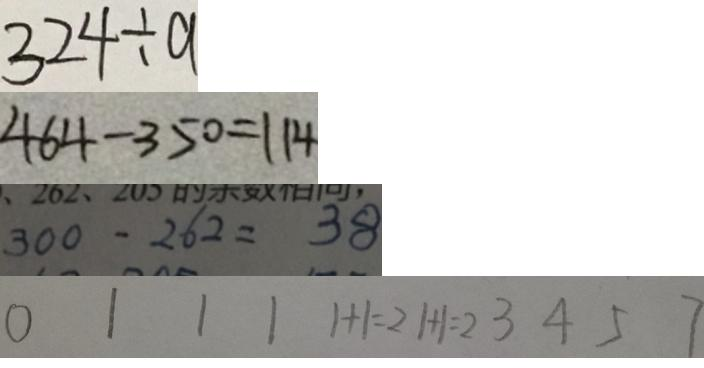Convert formula to latex. <formula><loc_0><loc_0><loc_500><loc_500>3 2 4 \div a 
 4 6 4 - 3 5 0 = 1 1 4 
 3 0 0 - 2 6 2 = 3 8 
 0 1 1 1 1 + 1 = 2 1 + 1 = 2 3 4 5 7</formula> 